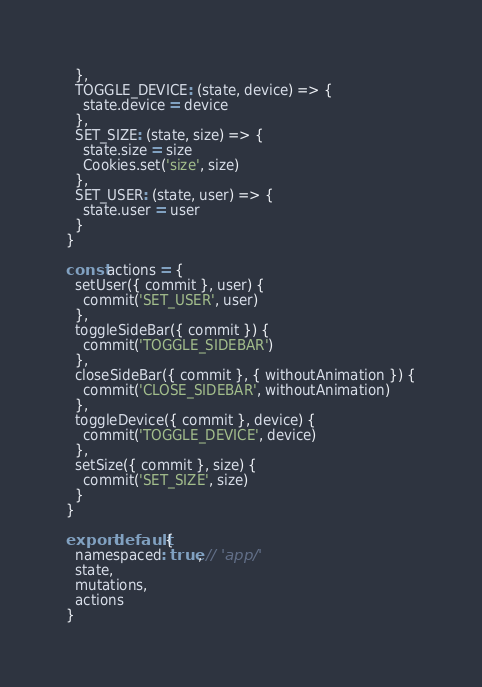Convert code to text. <code><loc_0><loc_0><loc_500><loc_500><_JavaScript_>  },
  TOGGLE_DEVICE: (state, device) => {
    state.device = device
  },
  SET_SIZE: (state, size) => {
    state.size = size
    Cookies.set('size', size)
  },
  SET_USER: (state, user) => {
    state.user = user
  }
}

const actions = {
  setUser({ commit }, user) {
    commit('SET_USER', user)
  },
  toggleSideBar({ commit }) {
    commit('TOGGLE_SIDEBAR')
  },
  closeSideBar({ commit }, { withoutAnimation }) {
    commit('CLOSE_SIDEBAR', withoutAnimation)
  },
  toggleDevice({ commit }, device) {
    commit('TOGGLE_DEVICE', device)
  },
  setSize({ commit }, size) {
    commit('SET_SIZE', size)
  }
}

export default {
  namespaced: true, // 'app/'
  state,
  mutations,
  actions
}
</code> 